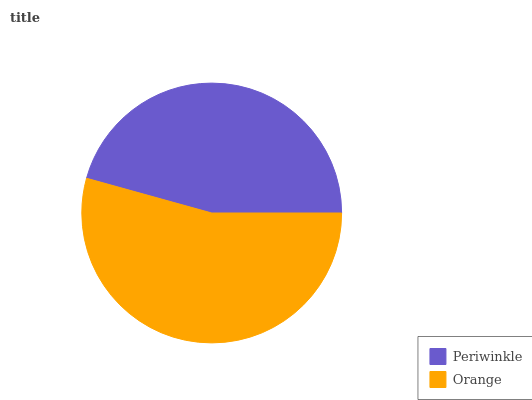Is Periwinkle the minimum?
Answer yes or no. Yes. Is Orange the maximum?
Answer yes or no. Yes. Is Orange the minimum?
Answer yes or no. No. Is Orange greater than Periwinkle?
Answer yes or no. Yes. Is Periwinkle less than Orange?
Answer yes or no. Yes. Is Periwinkle greater than Orange?
Answer yes or no. No. Is Orange less than Periwinkle?
Answer yes or no. No. Is Orange the high median?
Answer yes or no. Yes. Is Periwinkle the low median?
Answer yes or no. Yes. Is Periwinkle the high median?
Answer yes or no. No. Is Orange the low median?
Answer yes or no. No. 